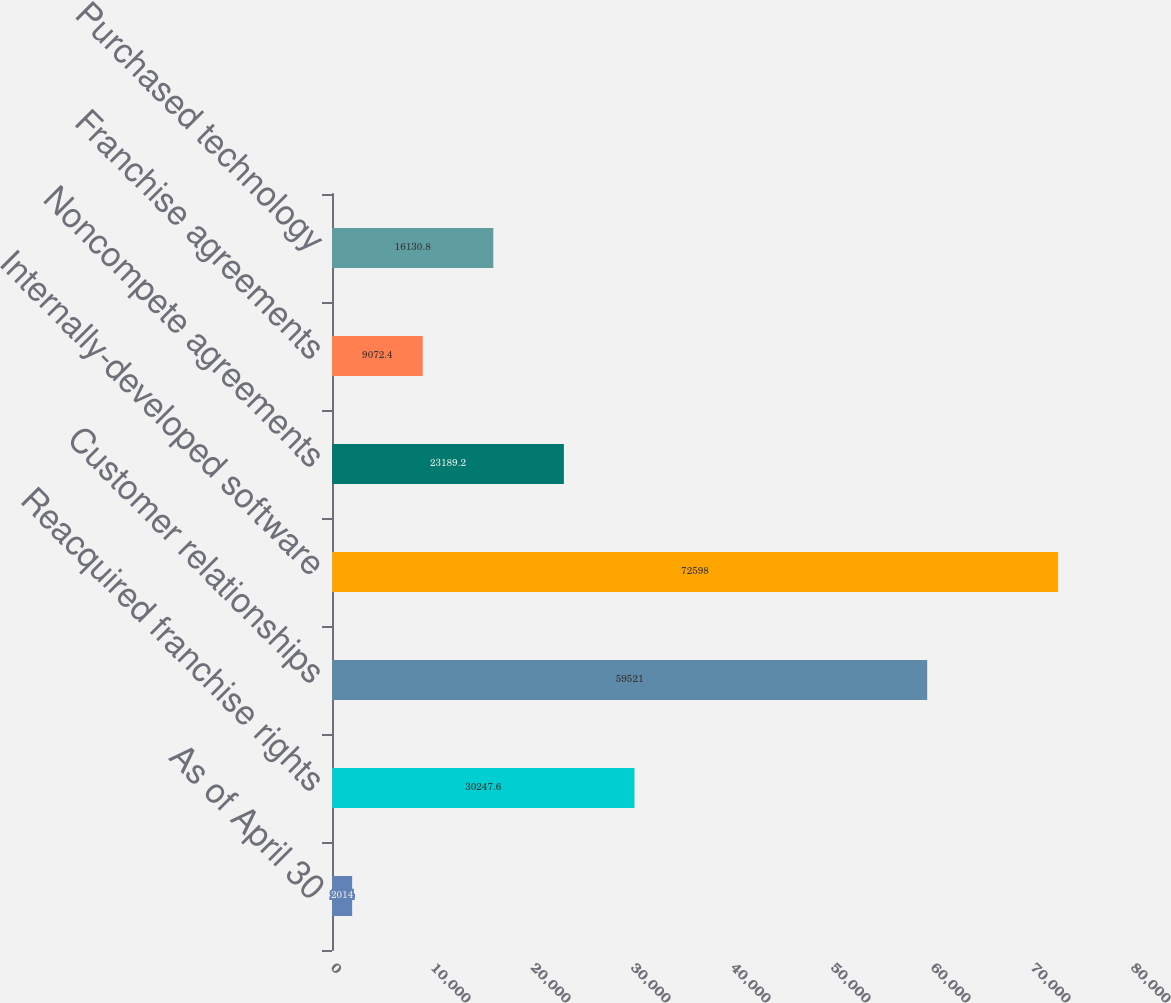<chart> <loc_0><loc_0><loc_500><loc_500><bar_chart><fcel>As of April 30<fcel>Reacquired franchise rights<fcel>Customer relationships<fcel>Internally-developed software<fcel>Noncompete agreements<fcel>Franchise agreements<fcel>Purchased technology<nl><fcel>2014<fcel>30247.6<fcel>59521<fcel>72598<fcel>23189.2<fcel>9072.4<fcel>16130.8<nl></chart> 